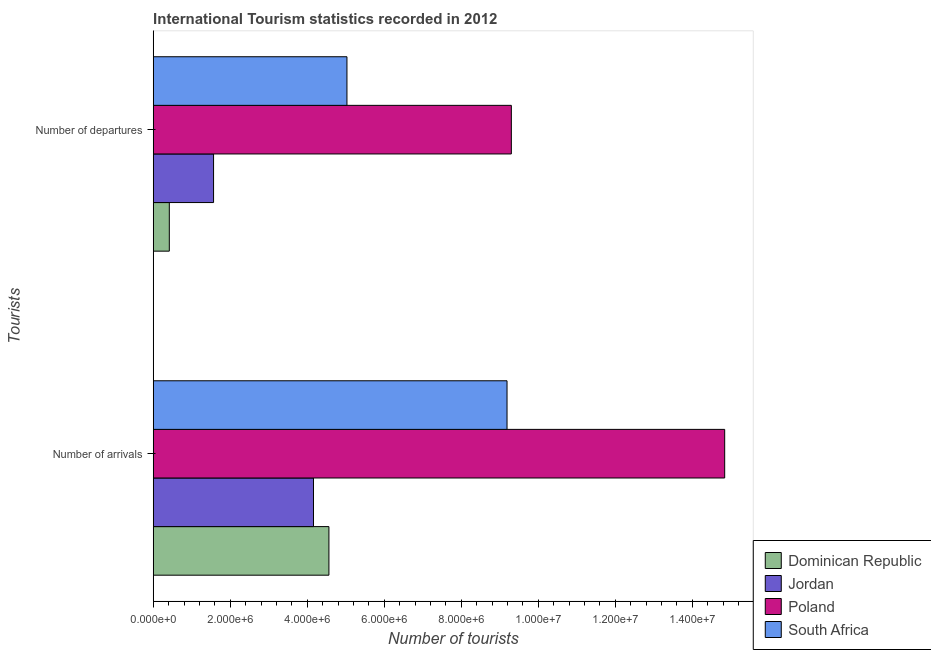How many different coloured bars are there?
Offer a very short reply. 4. Are the number of bars per tick equal to the number of legend labels?
Ensure brevity in your answer.  Yes. Are the number of bars on each tick of the Y-axis equal?
Your answer should be compact. Yes. How many bars are there on the 1st tick from the top?
Ensure brevity in your answer.  4. What is the label of the 2nd group of bars from the top?
Provide a short and direct response. Number of arrivals. What is the number of tourist arrivals in Dominican Republic?
Offer a terse response. 4.56e+06. Across all countries, what is the maximum number of tourist departures?
Your answer should be very brief. 9.30e+06. Across all countries, what is the minimum number of tourist departures?
Offer a very short reply. 4.18e+05. In which country was the number of tourist departures maximum?
Provide a short and direct response. Poland. In which country was the number of tourist arrivals minimum?
Offer a very short reply. Jordan. What is the total number of tourist departures in the graph?
Provide a short and direct response. 1.63e+07. What is the difference between the number of tourist arrivals in Poland and that in South Africa?
Your answer should be compact. 5.65e+06. What is the difference between the number of tourist departures in Poland and the number of tourist arrivals in Dominican Republic?
Keep it short and to the point. 4.74e+06. What is the average number of tourist departures per country?
Ensure brevity in your answer.  4.08e+06. What is the difference between the number of tourist arrivals and number of tourist departures in Poland?
Your answer should be compact. 5.54e+06. In how many countries, is the number of tourist departures greater than 7600000 ?
Keep it short and to the point. 1. What is the ratio of the number of tourist departures in Jordan to that in South Africa?
Provide a succinct answer. 0.31. What does the 4th bar from the top in Number of departures represents?
Give a very brief answer. Dominican Republic. What does the 2nd bar from the bottom in Number of departures represents?
Keep it short and to the point. Jordan. How many bars are there?
Your answer should be very brief. 8. How many countries are there in the graph?
Provide a short and direct response. 4. Where does the legend appear in the graph?
Provide a succinct answer. Bottom right. What is the title of the graph?
Provide a succinct answer. International Tourism statistics recorded in 2012. Does "Guam" appear as one of the legend labels in the graph?
Keep it short and to the point. No. What is the label or title of the X-axis?
Your response must be concise. Number of tourists. What is the label or title of the Y-axis?
Give a very brief answer. Tourists. What is the Number of tourists of Dominican Republic in Number of arrivals?
Keep it short and to the point. 4.56e+06. What is the Number of tourists of Jordan in Number of arrivals?
Offer a very short reply. 4.16e+06. What is the Number of tourists of Poland in Number of arrivals?
Ensure brevity in your answer.  1.48e+07. What is the Number of tourists in South Africa in Number of arrivals?
Your answer should be very brief. 9.19e+06. What is the Number of tourists of Dominican Republic in Number of departures?
Ensure brevity in your answer.  4.18e+05. What is the Number of tourists of Jordan in Number of departures?
Offer a terse response. 1.57e+06. What is the Number of tourists of Poland in Number of departures?
Keep it short and to the point. 9.30e+06. What is the Number of tourists in South Africa in Number of departures?
Offer a very short reply. 5.03e+06. Across all Tourists, what is the maximum Number of tourists of Dominican Republic?
Provide a short and direct response. 4.56e+06. Across all Tourists, what is the maximum Number of tourists of Jordan?
Offer a very short reply. 4.16e+06. Across all Tourists, what is the maximum Number of tourists of Poland?
Ensure brevity in your answer.  1.48e+07. Across all Tourists, what is the maximum Number of tourists of South Africa?
Your answer should be very brief. 9.19e+06. Across all Tourists, what is the minimum Number of tourists of Dominican Republic?
Provide a succinct answer. 4.18e+05. Across all Tourists, what is the minimum Number of tourists of Jordan?
Make the answer very short. 1.57e+06. Across all Tourists, what is the minimum Number of tourists of Poland?
Offer a terse response. 9.30e+06. Across all Tourists, what is the minimum Number of tourists of South Africa?
Offer a terse response. 5.03e+06. What is the total Number of tourists in Dominican Republic in the graph?
Your response must be concise. 4.98e+06. What is the total Number of tourists of Jordan in the graph?
Offer a very short reply. 5.73e+06. What is the total Number of tourists in Poland in the graph?
Your answer should be very brief. 2.41e+07. What is the total Number of tourists in South Africa in the graph?
Offer a terse response. 1.42e+07. What is the difference between the Number of tourists of Dominican Republic in Number of arrivals and that in Number of departures?
Offer a terse response. 4.14e+06. What is the difference between the Number of tourists of Jordan in Number of arrivals and that in Number of departures?
Your answer should be compact. 2.60e+06. What is the difference between the Number of tourists of Poland in Number of arrivals and that in Number of departures?
Give a very brief answer. 5.54e+06. What is the difference between the Number of tourists in South Africa in Number of arrivals and that in Number of departures?
Offer a terse response. 4.16e+06. What is the difference between the Number of tourists in Dominican Republic in Number of arrivals and the Number of tourists in Jordan in Number of departures?
Provide a short and direct response. 3.00e+06. What is the difference between the Number of tourists of Dominican Republic in Number of arrivals and the Number of tourists of Poland in Number of departures?
Offer a very short reply. -4.74e+06. What is the difference between the Number of tourists of Dominican Republic in Number of arrivals and the Number of tourists of South Africa in Number of departures?
Keep it short and to the point. -4.68e+05. What is the difference between the Number of tourists of Jordan in Number of arrivals and the Number of tourists of Poland in Number of departures?
Your response must be concise. -5.14e+06. What is the difference between the Number of tourists of Jordan in Number of arrivals and the Number of tourists of South Africa in Number of departures?
Offer a very short reply. -8.69e+05. What is the difference between the Number of tourists in Poland in Number of arrivals and the Number of tourists in South Africa in Number of departures?
Make the answer very short. 9.81e+06. What is the average Number of tourists of Dominican Republic per Tourists?
Your response must be concise. 2.49e+06. What is the average Number of tourists in Jordan per Tourists?
Your answer should be compact. 2.86e+06. What is the average Number of tourists in Poland per Tourists?
Give a very brief answer. 1.21e+07. What is the average Number of tourists in South Africa per Tourists?
Keep it short and to the point. 7.11e+06. What is the difference between the Number of tourists in Dominican Republic and Number of tourists in Jordan in Number of arrivals?
Offer a terse response. 4.01e+05. What is the difference between the Number of tourists of Dominican Republic and Number of tourists of Poland in Number of arrivals?
Your answer should be compact. -1.03e+07. What is the difference between the Number of tourists in Dominican Republic and Number of tourists in South Africa in Number of arrivals?
Provide a succinct answer. -4.62e+06. What is the difference between the Number of tourists in Jordan and Number of tourists in Poland in Number of arrivals?
Ensure brevity in your answer.  -1.07e+07. What is the difference between the Number of tourists of Jordan and Number of tourists of South Africa in Number of arrivals?
Your answer should be compact. -5.03e+06. What is the difference between the Number of tourists of Poland and Number of tourists of South Africa in Number of arrivals?
Make the answer very short. 5.65e+06. What is the difference between the Number of tourists of Dominican Republic and Number of tourists of Jordan in Number of departures?
Your answer should be compact. -1.15e+06. What is the difference between the Number of tourists in Dominican Republic and Number of tourists in Poland in Number of departures?
Your answer should be compact. -8.88e+06. What is the difference between the Number of tourists of Dominican Republic and Number of tourists of South Africa in Number of departures?
Provide a short and direct response. -4.61e+06. What is the difference between the Number of tourists in Jordan and Number of tourists in Poland in Number of departures?
Your answer should be very brief. -7.73e+06. What is the difference between the Number of tourists in Jordan and Number of tourists in South Africa in Number of departures?
Keep it short and to the point. -3.46e+06. What is the difference between the Number of tourists of Poland and Number of tourists of South Africa in Number of departures?
Offer a very short reply. 4.27e+06. What is the ratio of the Number of tourists in Dominican Republic in Number of arrivals to that in Number of departures?
Make the answer very short. 10.92. What is the ratio of the Number of tourists of Jordan in Number of arrivals to that in Number of departures?
Make the answer very short. 2.66. What is the ratio of the Number of tourists of Poland in Number of arrivals to that in Number of departures?
Offer a terse response. 1.6. What is the ratio of the Number of tourists in South Africa in Number of arrivals to that in Number of departures?
Offer a terse response. 1.83. What is the difference between the highest and the second highest Number of tourists in Dominican Republic?
Keep it short and to the point. 4.14e+06. What is the difference between the highest and the second highest Number of tourists in Jordan?
Provide a short and direct response. 2.60e+06. What is the difference between the highest and the second highest Number of tourists in Poland?
Give a very brief answer. 5.54e+06. What is the difference between the highest and the second highest Number of tourists of South Africa?
Your response must be concise. 4.16e+06. What is the difference between the highest and the lowest Number of tourists in Dominican Republic?
Provide a succinct answer. 4.14e+06. What is the difference between the highest and the lowest Number of tourists of Jordan?
Your answer should be very brief. 2.60e+06. What is the difference between the highest and the lowest Number of tourists in Poland?
Offer a terse response. 5.54e+06. What is the difference between the highest and the lowest Number of tourists of South Africa?
Keep it short and to the point. 4.16e+06. 